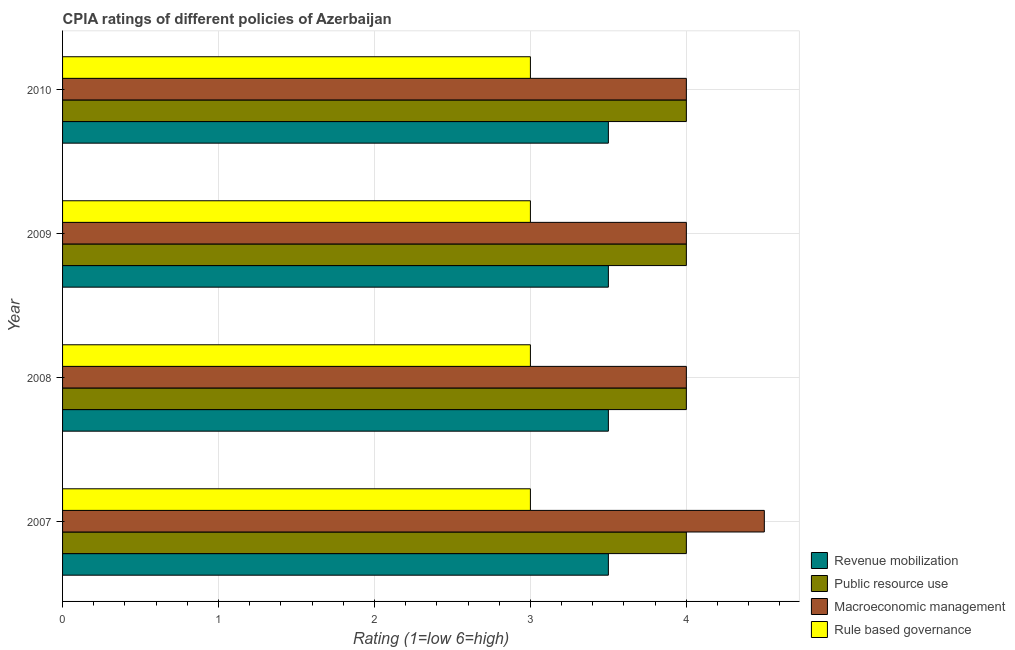How many different coloured bars are there?
Provide a succinct answer. 4. How many groups of bars are there?
Provide a succinct answer. 4. Are the number of bars per tick equal to the number of legend labels?
Ensure brevity in your answer.  Yes. Are the number of bars on each tick of the Y-axis equal?
Keep it short and to the point. Yes. How many bars are there on the 1st tick from the top?
Give a very brief answer. 4. How many bars are there on the 4th tick from the bottom?
Provide a short and direct response. 4. What is the label of the 1st group of bars from the top?
Offer a terse response. 2010. In how many cases, is the number of bars for a given year not equal to the number of legend labels?
Provide a succinct answer. 0. What is the cpia rating of rule based governance in 2009?
Ensure brevity in your answer.  3. Across all years, what is the maximum cpia rating of rule based governance?
Offer a very short reply. 3. What is the ratio of the cpia rating of public resource use in 2007 to that in 2009?
Your answer should be compact. 1. Is the cpia rating of public resource use in 2008 less than that in 2010?
Your response must be concise. No. What is the difference between the highest and the second highest cpia rating of public resource use?
Offer a terse response. 0. What is the difference between the highest and the lowest cpia rating of revenue mobilization?
Your answer should be very brief. 0. In how many years, is the cpia rating of macroeconomic management greater than the average cpia rating of macroeconomic management taken over all years?
Make the answer very short. 1. Is the sum of the cpia rating of rule based governance in 2008 and 2009 greater than the maximum cpia rating of macroeconomic management across all years?
Offer a terse response. Yes. What does the 2nd bar from the top in 2007 represents?
Provide a short and direct response. Macroeconomic management. What does the 3rd bar from the bottom in 2008 represents?
Provide a succinct answer. Macroeconomic management. Are all the bars in the graph horizontal?
Ensure brevity in your answer.  Yes. Does the graph contain any zero values?
Provide a short and direct response. No. How many legend labels are there?
Offer a terse response. 4. What is the title of the graph?
Keep it short and to the point. CPIA ratings of different policies of Azerbaijan. Does "Korea" appear as one of the legend labels in the graph?
Make the answer very short. No. What is the label or title of the Y-axis?
Give a very brief answer. Year. What is the Rating (1=low 6=high) in Revenue mobilization in 2007?
Offer a very short reply. 3.5. What is the Rating (1=low 6=high) of Macroeconomic management in 2007?
Offer a terse response. 4.5. What is the Rating (1=low 6=high) in Rule based governance in 2007?
Your answer should be compact. 3. What is the Rating (1=low 6=high) of Public resource use in 2008?
Offer a terse response. 4. What is the Rating (1=low 6=high) of Macroeconomic management in 2008?
Provide a short and direct response. 4. What is the Rating (1=low 6=high) in Rule based governance in 2008?
Provide a short and direct response. 3. What is the Rating (1=low 6=high) of Revenue mobilization in 2009?
Your answer should be very brief. 3.5. What is the Rating (1=low 6=high) in Macroeconomic management in 2009?
Ensure brevity in your answer.  4. What is the Rating (1=low 6=high) of Revenue mobilization in 2010?
Provide a succinct answer. 3.5. What is the Rating (1=low 6=high) in Public resource use in 2010?
Your response must be concise. 4. What is the Rating (1=low 6=high) of Rule based governance in 2010?
Give a very brief answer. 3. Across all years, what is the maximum Rating (1=low 6=high) of Public resource use?
Provide a short and direct response. 4. Across all years, what is the maximum Rating (1=low 6=high) of Macroeconomic management?
Your response must be concise. 4.5. Across all years, what is the minimum Rating (1=low 6=high) of Public resource use?
Give a very brief answer. 4. What is the total Rating (1=low 6=high) of Revenue mobilization in the graph?
Make the answer very short. 14. What is the total Rating (1=low 6=high) in Macroeconomic management in the graph?
Your answer should be very brief. 16.5. What is the total Rating (1=low 6=high) in Rule based governance in the graph?
Offer a terse response. 12. What is the difference between the Rating (1=low 6=high) of Revenue mobilization in 2007 and that in 2008?
Ensure brevity in your answer.  0. What is the difference between the Rating (1=low 6=high) in Rule based governance in 2007 and that in 2008?
Provide a short and direct response. 0. What is the difference between the Rating (1=low 6=high) in Public resource use in 2007 and that in 2009?
Keep it short and to the point. 0. What is the difference between the Rating (1=low 6=high) in Revenue mobilization in 2007 and that in 2010?
Offer a very short reply. 0. What is the difference between the Rating (1=low 6=high) in Rule based governance in 2007 and that in 2010?
Your response must be concise. 0. What is the difference between the Rating (1=low 6=high) of Macroeconomic management in 2008 and that in 2009?
Give a very brief answer. 0. What is the difference between the Rating (1=low 6=high) of Rule based governance in 2008 and that in 2010?
Your response must be concise. 0. What is the difference between the Rating (1=low 6=high) in Public resource use in 2009 and that in 2010?
Offer a very short reply. 0. What is the difference between the Rating (1=low 6=high) in Macroeconomic management in 2009 and that in 2010?
Your response must be concise. 0. What is the difference between the Rating (1=low 6=high) in Public resource use in 2007 and the Rating (1=low 6=high) in Macroeconomic management in 2008?
Offer a very short reply. 0. What is the difference between the Rating (1=low 6=high) in Public resource use in 2007 and the Rating (1=low 6=high) in Rule based governance in 2008?
Offer a very short reply. 1. What is the difference between the Rating (1=low 6=high) of Macroeconomic management in 2007 and the Rating (1=low 6=high) of Rule based governance in 2008?
Your response must be concise. 1.5. What is the difference between the Rating (1=low 6=high) in Revenue mobilization in 2007 and the Rating (1=low 6=high) in Rule based governance in 2009?
Keep it short and to the point. 0.5. What is the difference between the Rating (1=low 6=high) of Public resource use in 2007 and the Rating (1=low 6=high) of Rule based governance in 2009?
Offer a very short reply. 1. What is the difference between the Rating (1=low 6=high) of Public resource use in 2007 and the Rating (1=low 6=high) of Macroeconomic management in 2010?
Make the answer very short. 0. What is the difference between the Rating (1=low 6=high) in Public resource use in 2007 and the Rating (1=low 6=high) in Rule based governance in 2010?
Your answer should be compact. 1. What is the difference between the Rating (1=low 6=high) in Macroeconomic management in 2007 and the Rating (1=low 6=high) in Rule based governance in 2010?
Keep it short and to the point. 1.5. What is the difference between the Rating (1=low 6=high) of Revenue mobilization in 2008 and the Rating (1=low 6=high) of Public resource use in 2009?
Ensure brevity in your answer.  -0.5. What is the difference between the Rating (1=low 6=high) in Revenue mobilization in 2008 and the Rating (1=low 6=high) in Macroeconomic management in 2009?
Keep it short and to the point. -0.5. What is the difference between the Rating (1=low 6=high) in Revenue mobilization in 2008 and the Rating (1=low 6=high) in Rule based governance in 2009?
Offer a terse response. 0.5. What is the difference between the Rating (1=low 6=high) of Public resource use in 2008 and the Rating (1=low 6=high) of Macroeconomic management in 2009?
Your answer should be compact. 0. What is the difference between the Rating (1=low 6=high) in Revenue mobilization in 2008 and the Rating (1=low 6=high) in Macroeconomic management in 2010?
Give a very brief answer. -0.5. What is the difference between the Rating (1=low 6=high) in Revenue mobilization in 2008 and the Rating (1=low 6=high) in Rule based governance in 2010?
Your answer should be compact. 0.5. What is the difference between the Rating (1=low 6=high) of Public resource use in 2008 and the Rating (1=low 6=high) of Rule based governance in 2010?
Your answer should be compact. 1. What is the difference between the Rating (1=low 6=high) in Macroeconomic management in 2008 and the Rating (1=low 6=high) in Rule based governance in 2010?
Offer a terse response. 1. What is the difference between the Rating (1=low 6=high) in Revenue mobilization in 2009 and the Rating (1=low 6=high) in Macroeconomic management in 2010?
Give a very brief answer. -0.5. What is the difference between the Rating (1=low 6=high) in Revenue mobilization in 2009 and the Rating (1=low 6=high) in Rule based governance in 2010?
Keep it short and to the point. 0.5. What is the difference between the Rating (1=low 6=high) of Public resource use in 2009 and the Rating (1=low 6=high) of Rule based governance in 2010?
Offer a very short reply. 1. What is the difference between the Rating (1=low 6=high) in Macroeconomic management in 2009 and the Rating (1=low 6=high) in Rule based governance in 2010?
Provide a succinct answer. 1. What is the average Rating (1=low 6=high) of Macroeconomic management per year?
Your answer should be very brief. 4.12. In the year 2007, what is the difference between the Rating (1=low 6=high) of Revenue mobilization and Rating (1=low 6=high) of Rule based governance?
Give a very brief answer. 0.5. In the year 2007, what is the difference between the Rating (1=low 6=high) in Public resource use and Rating (1=low 6=high) in Macroeconomic management?
Make the answer very short. -0.5. In the year 2008, what is the difference between the Rating (1=low 6=high) in Revenue mobilization and Rating (1=low 6=high) in Public resource use?
Your response must be concise. -0.5. In the year 2008, what is the difference between the Rating (1=low 6=high) of Revenue mobilization and Rating (1=low 6=high) of Rule based governance?
Offer a very short reply. 0.5. In the year 2008, what is the difference between the Rating (1=low 6=high) of Macroeconomic management and Rating (1=low 6=high) of Rule based governance?
Offer a terse response. 1. In the year 2009, what is the difference between the Rating (1=low 6=high) in Revenue mobilization and Rating (1=low 6=high) in Public resource use?
Give a very brief answer. -0.5. In the year 2009, what is the difference between the Rating (1=low 6=high) of Revenue mobilization and Rating (1=low 6=high) of Macroeconomic management?
Keep it short and to the point. -0.5. In the year 2009, what is the difference between the Rating (1=low 6=high) of Revenue mobilization and Rating (1=low 6=high) of Rule based governance?
Make the answer very short. 0.5. In the year 2009, what is the difference between the Rating (1=low 6=high) in Public resource use and Rating (1=low 6=high) in Rule based governance?
Provide a succinct answer. 1. In the year 2010, what is the difference between the Rating (1=low 6=high) of Revenue mobilization and Rating (1=low 6=high) of Macroeconomic management?
Ensure brevity in your answer.  -0.5. In the year 2010, what is the difference between the Rating (1=low 6=high) of Revenue mobilization and Rating (1=low 6=high) of Rule based governance?
Give a very brief answer. 0.5. In the year 2010, what is the difference between the Rating (1=low 6=high) in Public resource use and Rating (1=low 6=high) in Macroeconomic management?
Make the answer very short. 0. In the year 2010, what is the difference between the Rating (1=low 6=high) of Public resource use and Rating (1=low 6=high) of Rule based governance?
Your answer should be compact. 1. In the year 2010, what is the difference between the Rating (1=low 6=high) of Macroeconomic management and Rating (1=low 6=high) of Rule based governance?
Offer a terse response. 1. What is the ratio of the Rating (1=low 6=high) of Macroeconomic management in 2007 to that in 2008?
Keep it short and to the point. 1.12. What is the ratio of the Rating (1=low 6=high) in Rule based governance in 2007 to that in 2008?
Provide a short and direct response. 1. What is the ratio of the Rating (1=low 6=high) in Public resource use in 2007 to that in 2009?
Ensure brevity in your answer.  1. What is the ratio of the Rating (1=low 6=high) in Macroeconomic management in 2007 to that in 2009?
Keep it short and to the point. 1.12. What is the ratio of the Rating (1=low 6=high) in Public resource use in 2007 to that in 2010?
Provide a short and direct response. 1. What is the ratio of the Rating (1=low 6=high) of Macroeconomic management in 2008 to that in 2009?
Make the answer very short. 1. What is the ratio of the Rating (1=low 6=high) of Rule based governance in 2008 to that in 2009?
Your answer should be very brief. 1. What is the ratio of the Rating (1=low 6=high) of Macroeconomic management in 2008 to that in 2010?
Offer a very short reply. 1. What is the ratio of the Rating (1=low 6=high) in Macroeconomic management in 2009 to that in 2010?
Offer a terse response. 1. What is the ratio of the Rating (1=low 6=high) in Rule based governance in 2009 to that in 2010?
Provide a succinct answer. 1. What is the difference between the highest and the second highest Rating (1=low 6=high) in Macroeconomic management?
Make the answer very short. 0.5. What is the difference between the highest and the lowest Rating (1=low 6=high) in Macroeconomic management?
Offer a very short reply. 0.5. What is the difference between the highest and the lowest Rating (1=low 6=high) in Rule based governance?
Offer a very short reply. 0. 